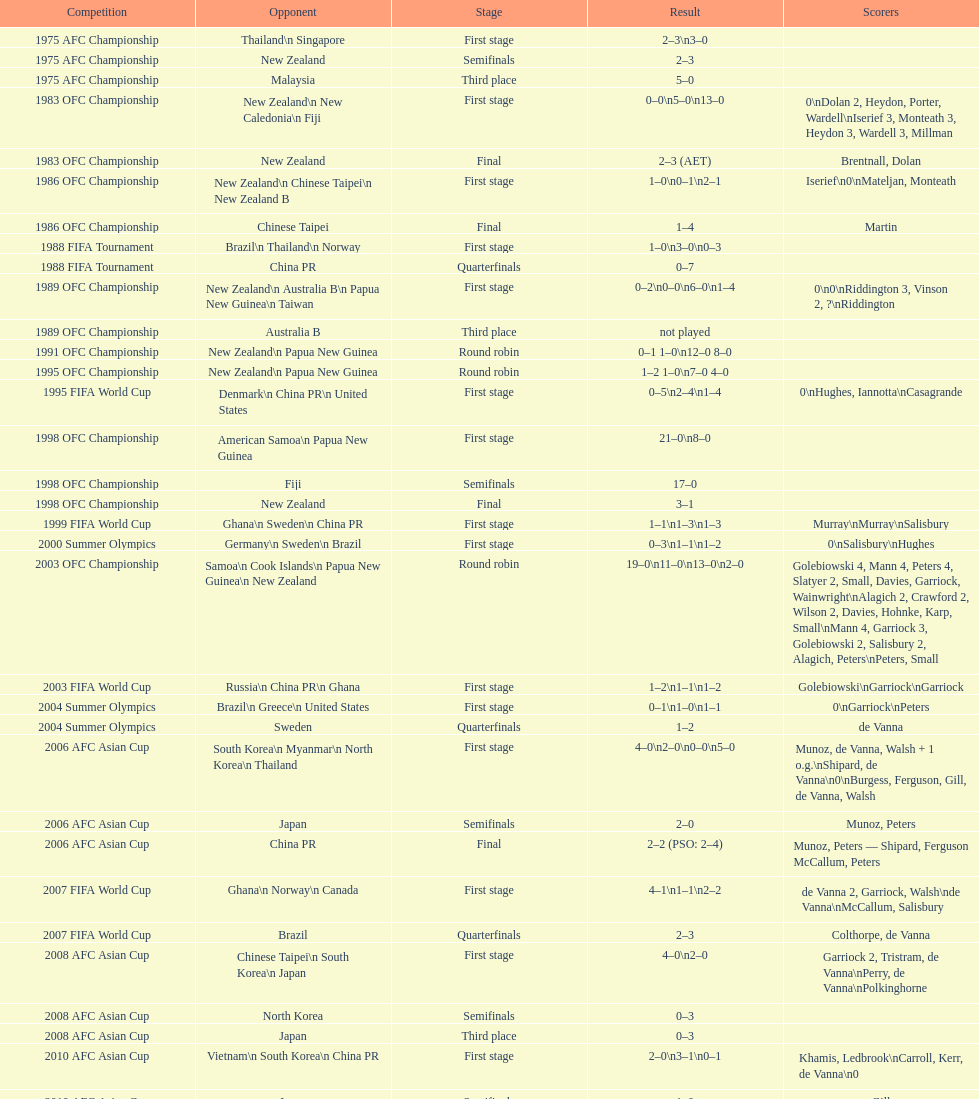How many players scored during the 1983 ofc championship competition? 9. 